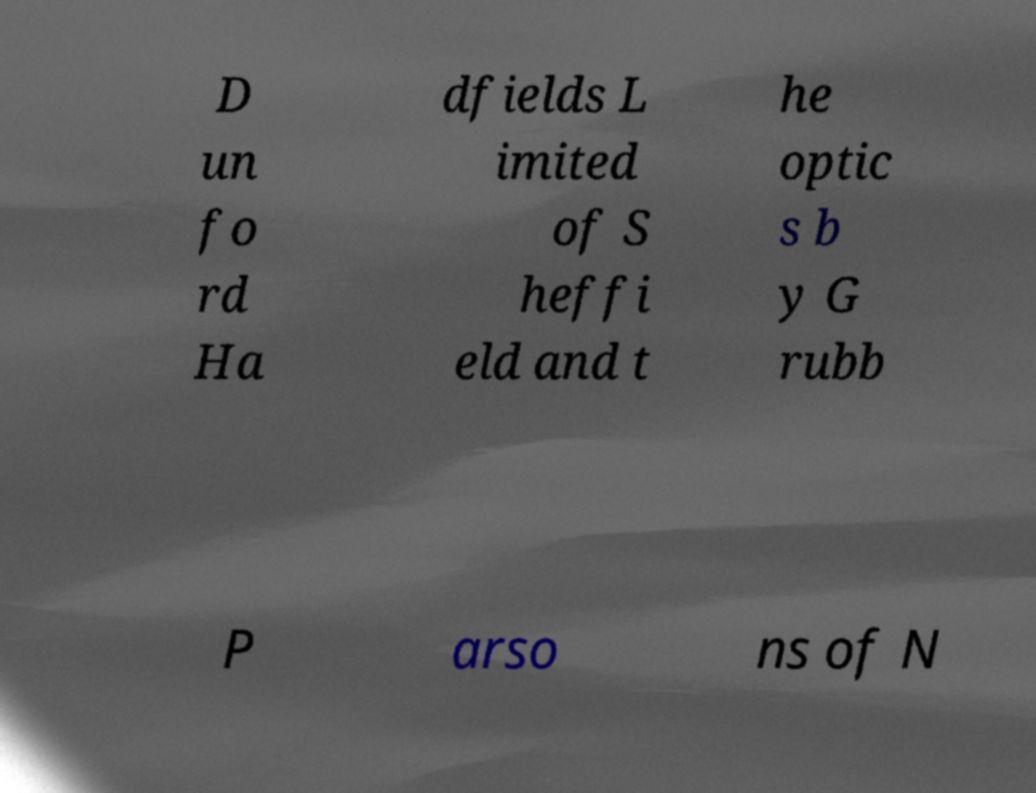What messages or text are displayed in this image? I need them in a readable, typed format. D un fo rd Ha dfields L imited of S heffi eld and t he optic s b y G rubb P arso ns of N 